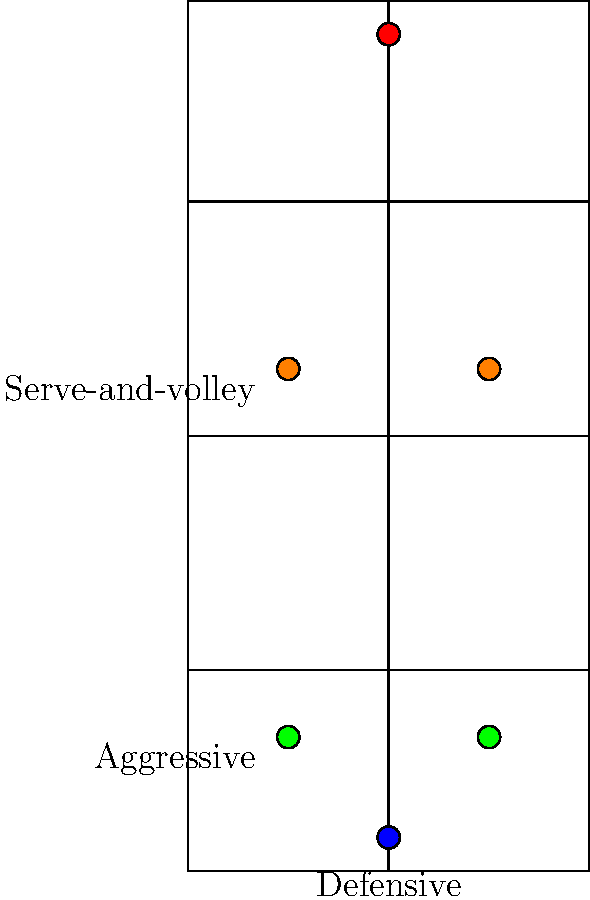As a professional tennis player, you understand the importance of court positioning for different playing styles. Based on the diagram, which playing style is represented by the green dots, and why is this position advantageous for that style? To answer this question, let's analyze the diagram step-by-step:

1. The blue dot at the bottom represents a defensive baseline position.
2. The red dot at the top represents the opponent's position.
3. The orange dots in the middle of the court represent a serve-and-volley style.
4. The green dots are positioned closer to the baseline but slightly inside the court.

The green dots represent an aggressive baseliner position. This position is advantageous for aggressive baseliners for several reasons:

1. Court coverage: By standing slightly inside the baseline, players can cover the court more effectively, reducing the time needed to reach wide balls.

2. Taking time away from opponents: This position allows players to take the ball earlier, giving opponents less time to recover between shots.

3. Angle creation: Being closer to the sidelines enables players to create sharper angles in their shots, opening up the court.

4. Transition to net: The slightly forward position makes it easier to transition to the net for approach shots or volleys when the opportunity arises.

5. Serve positioning: For serving, this position allows players to step into the court more easily, potentially adding more power to their serves.

This aggressive baseline position is commonly used by players who prefer to dictate play from the back of the court while maintaining the ability to move forward when necessary.
Answer: Aggressive baseliner 